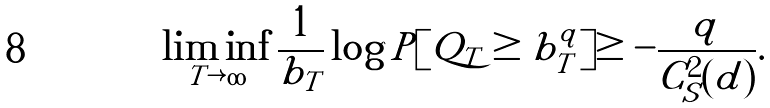<formula> <loc_0><loc_0><loc_500><loc_500>\liminf _ { T \rightarrow \infty } \frac { 1 } { b _ { T } } \log P [ { Q _ { T } \geq b _ { T } ^ { q } } ] \geq - \frac { q } { C _ { S } ^ { 2 } ( d ) } .</formula> 